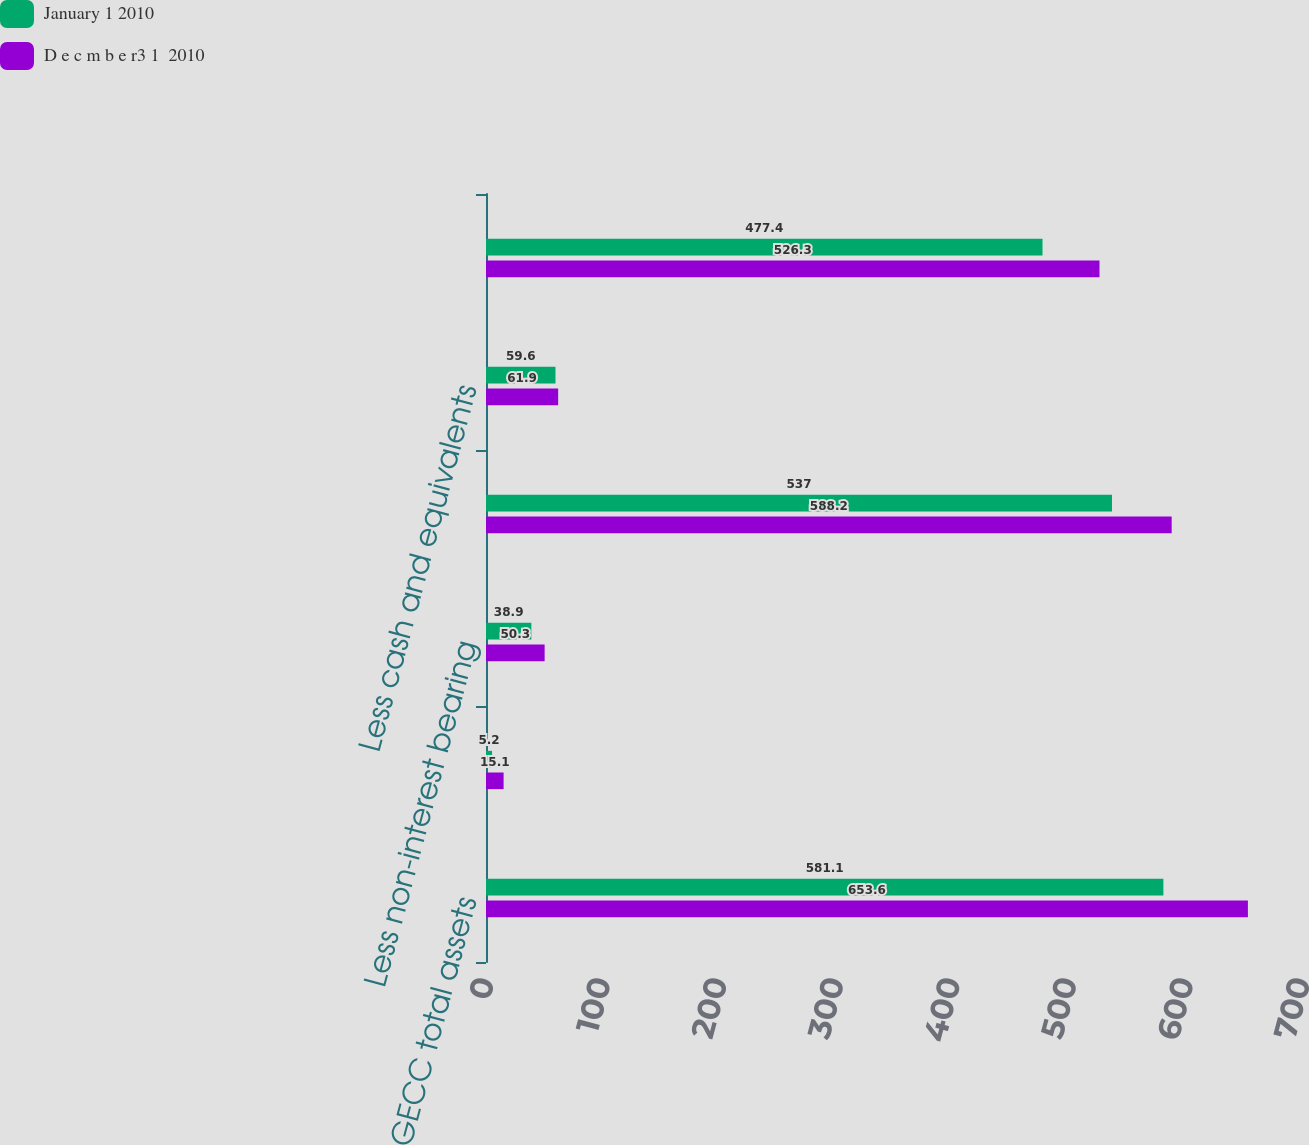Convert chart. <chart><loc_0><loc_0><loc_500><loc_500><stacked_bar_chart><ecel><fcel>GECC total assets<fcel>Less assets of discontinued<fcel>Less non-interest bearing<fcel>GE Capital ENI<fcel>Less cash and equivalents<fcel>GE Capital ENI excluding cash<nl><fcel>January 1 2010<fcel>581.1<fcel>5.2<fcel>38.9<fcel>537<fcel>59.6<fcel>477.4<nl><fcel>D e c m b e r3 1  2010<fcel>653.6<fcel>15.1<fcel>50.3<fcel>588.2<fcel>61.9<fcel>526.3<nl></chart> 